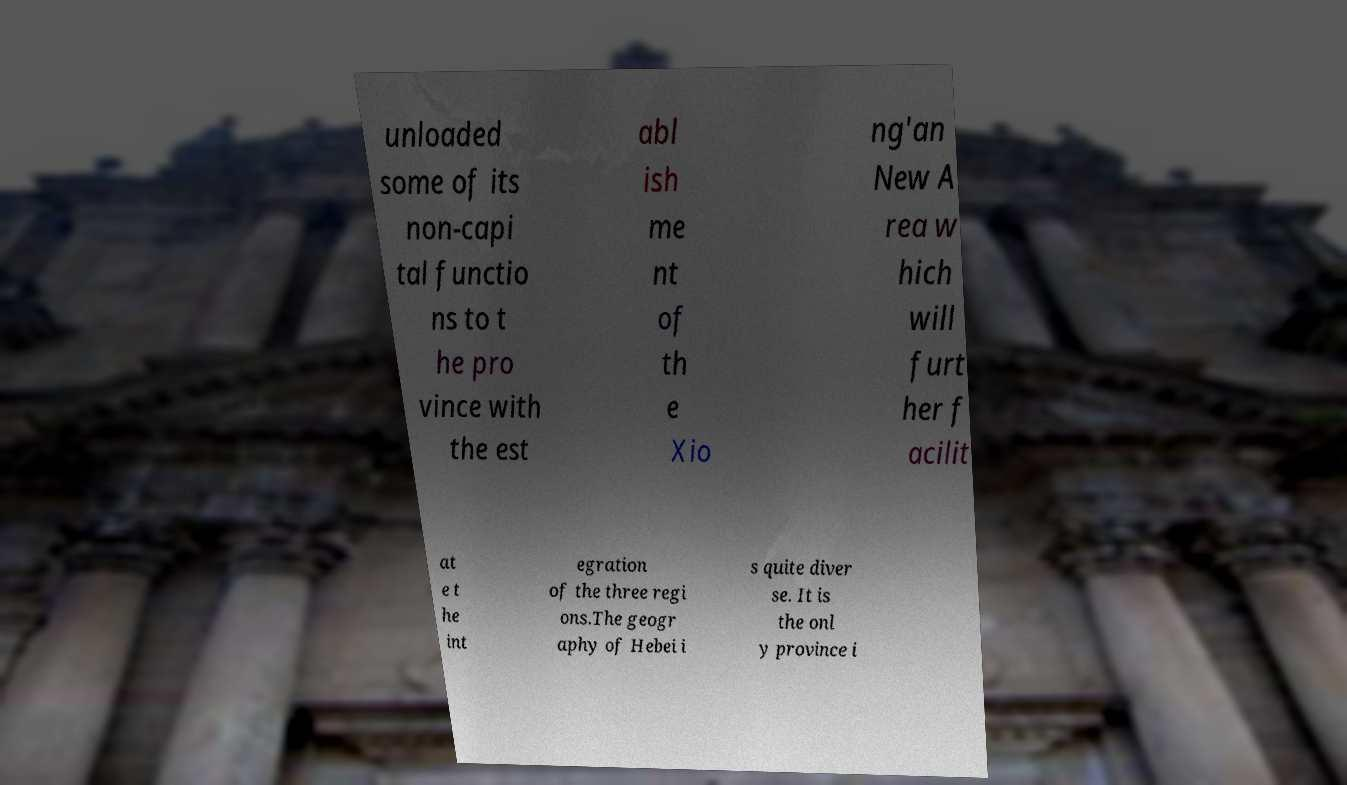What messages or text are displayed in this image? I need them in a readable, typed format. unloaded some of its non-capi tal functio ns to t he pro vince with the est abl ish me nt of th e Xio ng'an New A rea w hich will furt her f acilit at e t he int egration of the three regi ons.The geogr aphy of Hebei i s quite diver se. It is the onl y province i 